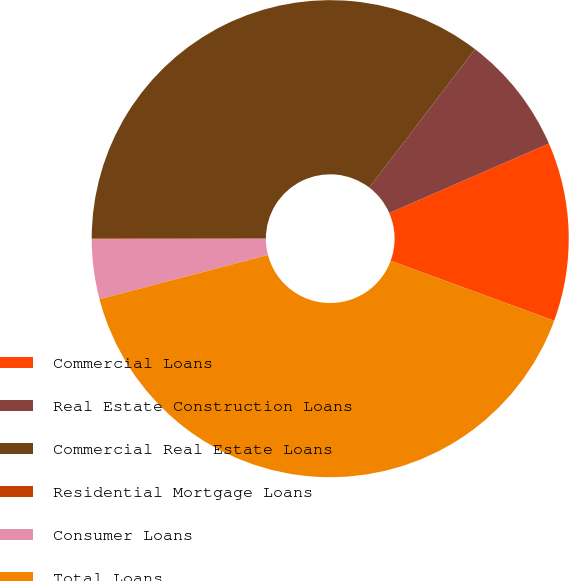Convert chart to OTSL. <chart><loc_0><loc_0><loc_500><loc_500><pie_chart><fcel>Commercial Loans<fcel>Real Estate Construction Loans<fcel>Commercial Real Estate Loans<fcel>Residential Mortgage Loans<fcel>Consumer Loans<fcel>Total Loans<nl><fcel>12.12%<fcel>8.09%<fcel>35.38%<fcel>0.03%<fcel>4.06%<fcel>40.33%<nl></chart> 